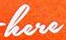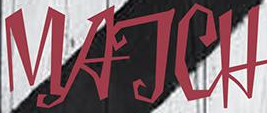Read the text content from these images in order, separated by a semicolon. here; MATCH 